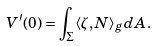Convert formula to latex. <formula><loc_0><loc_0><loc_500><loc_500>V ^ { \prime } ( 0 ) = \int _ { \Sigma } \langle \zeta , N \rangle _ { g } d A .</formula> 